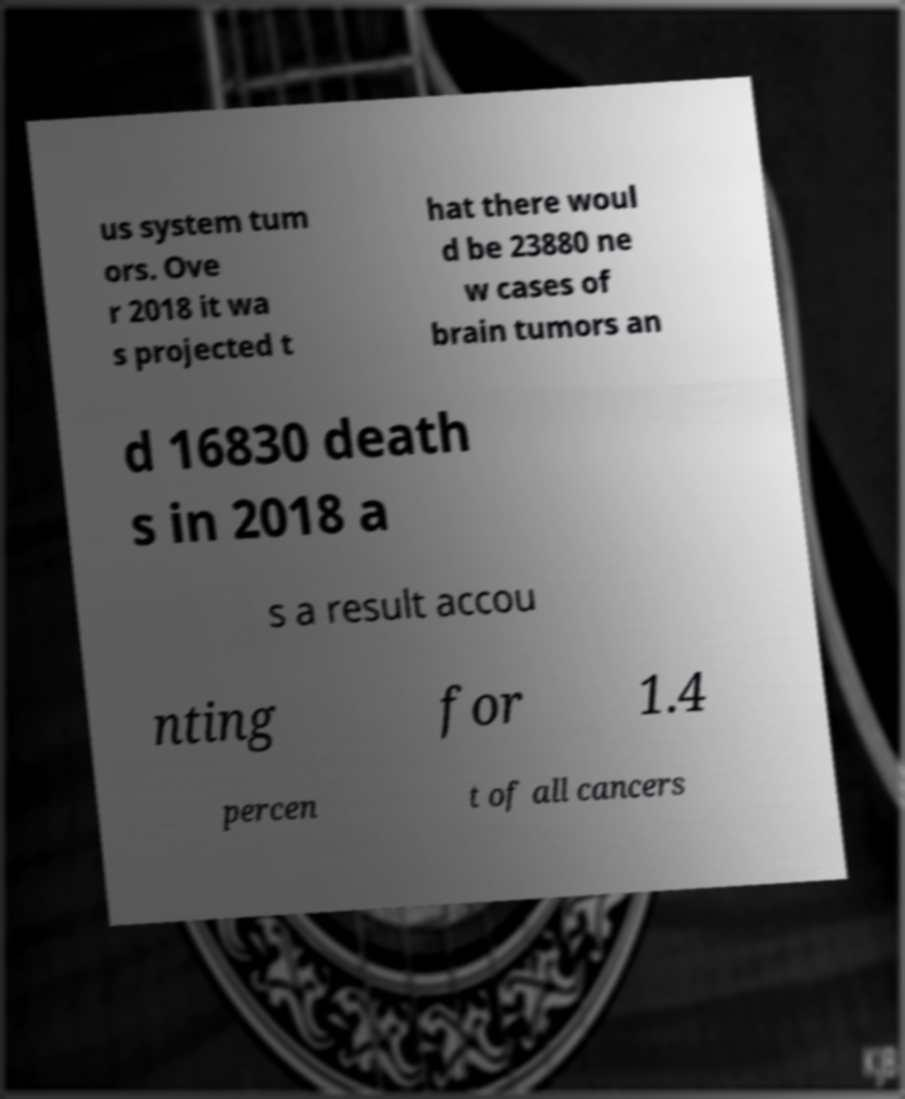Can you read and provide the text displayed in the image?This photo seems to have some interesting text. Can you extract and type it out for me? us system tum ors. Ove r 2018 it wa s projected t hat there woul d be 23880 ne w cases of brain tumors an d 16830 death s in 2018 a s a result accou nting for 1.4 percen t of all cancers 